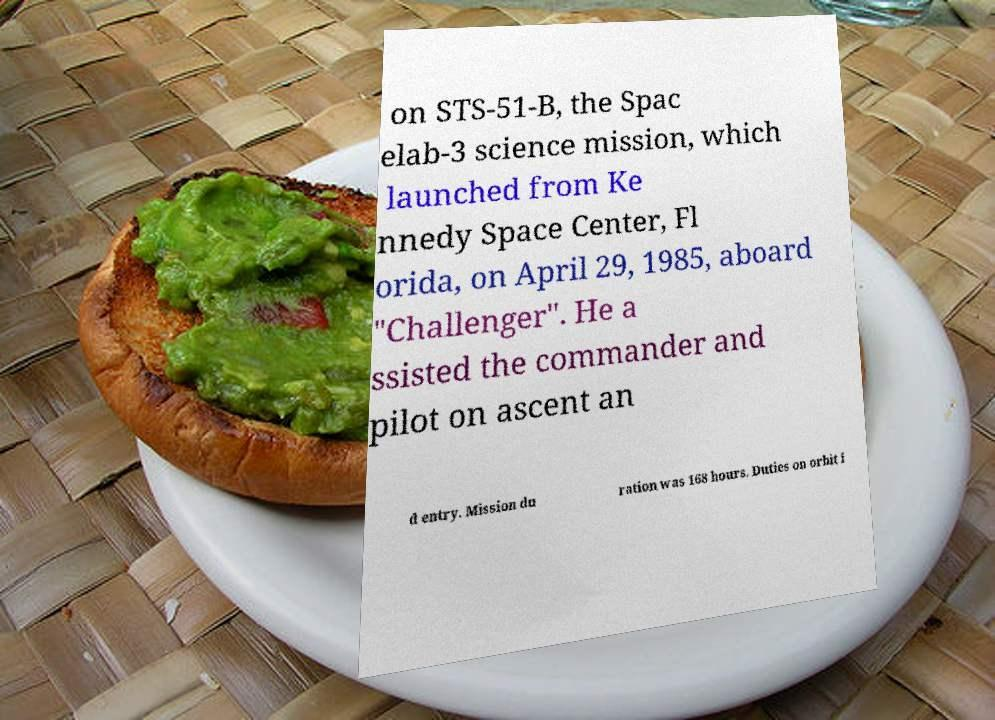Please read and relay the text visible in this image. What does it say? on STS-51-B, the Spac elab-3 science mission, which launched from Ke nnedy Space Center, Fl orida, on April 29, 1985, aboard "Challenger". He a ssisted the commander and pilot on ascent an d entry. Mission du ration was 168 hours. Duties on orbit i 